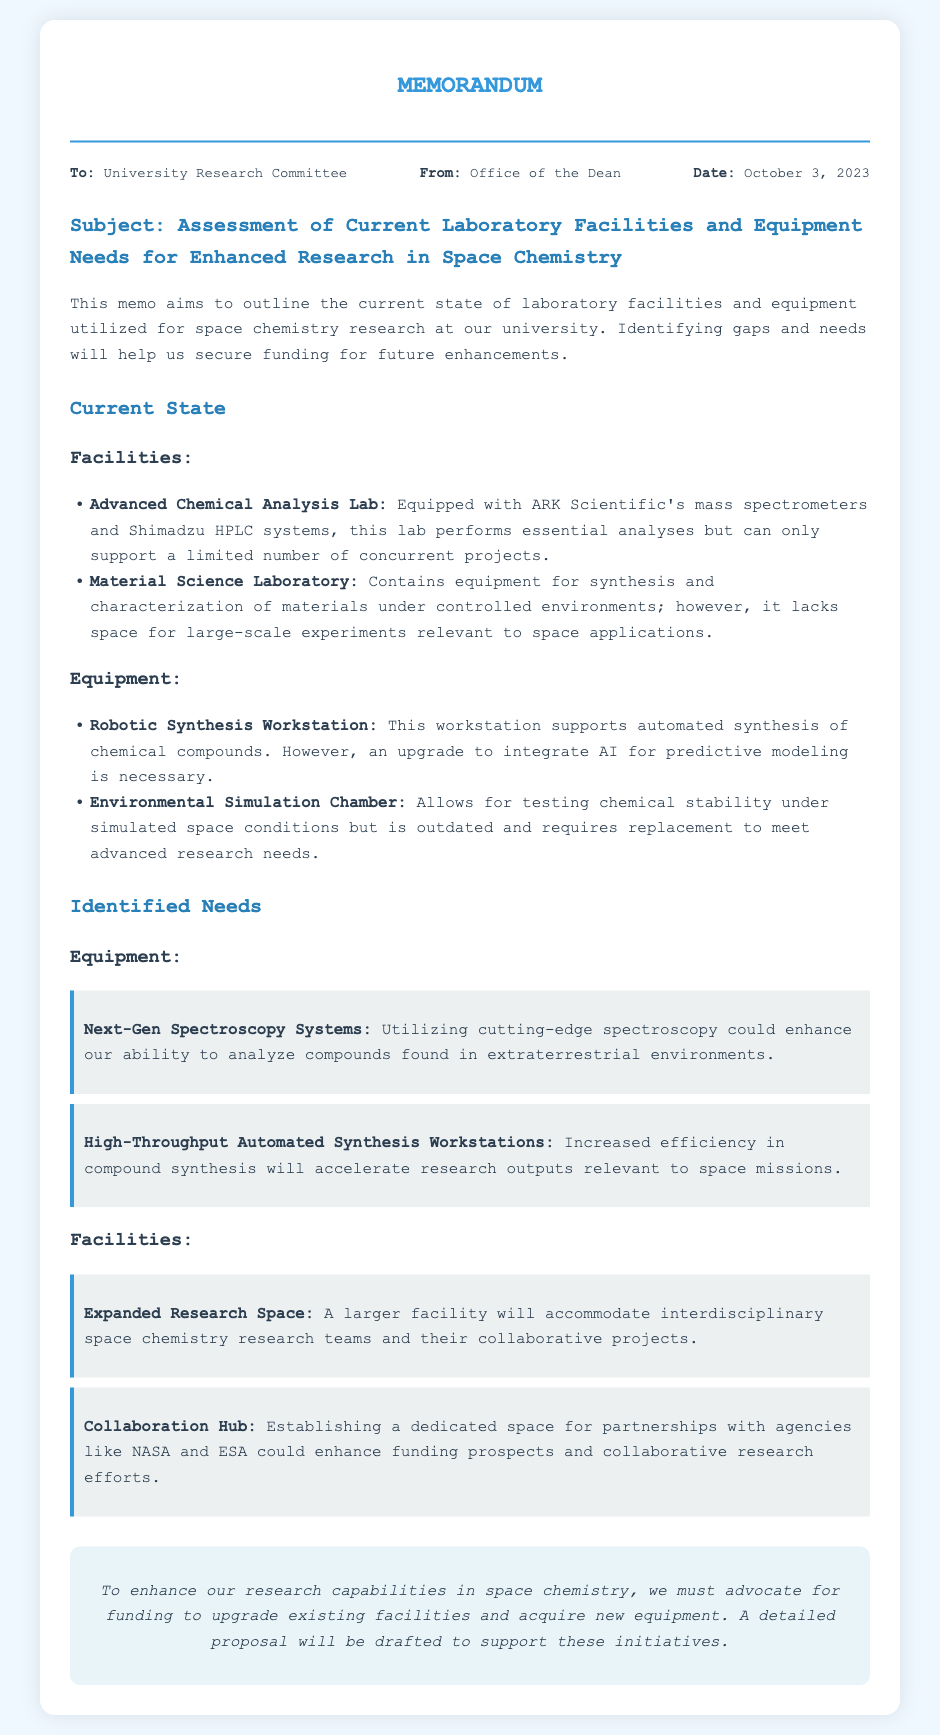What is the date of the memo? The date of the memo is indicated at the top as October 3, 2023.
Answer: October 3, 2023 Who is the memo addressed to? The memorandum specifies that it is addressed to the University Research Committee.
Answer: University Research Committee What is the main subject of the memo? The main subject focuses on the assessment of current laboratory facilities and equipment needs for enhanced research in space chemistry.
Answer: Assessment of Current Laboratory Facilities and Equipment Needs for Enhanced Research in Space Chemistry What type of equipment does the Advanced Chemical Analysis Lab use? The memo mentions that the lab is equipped with ARK Scientific's mass spectrometers and Shimadzu HPLC systems.
Answer: ARK Scientific's mass spectrometers and Shimadzu HPLC systems What is one identified need for equipment? The memo highlights that Next-Gen Spectroscopy Systems could enhance analysis capabilities for extraterrestrial compounds.
Answer: Next-Gen Spectroscopy Systems How many labs are specifically mentioned in the document? There are two laboratories specifically detailed in the memo: the Advanced Chemical Analysis Lab and the Material Science Laboratory.
Answer: Two What is the purpose of the expanded research space mentioned in the memo? The expanded research space aims to accommodate interdisciplinary space chemistry research teams and collaborative projects.
Answer: To accommodate interdisciplinary space chemistry research teams What could establishing a Collaboration Hub enhance? The Collaboration Hub might enhance funding prospects and collaborative research efforts with agencies like NASA and ESA.
Answer: Funding prospects and collaborative research efforts What will the Office of the Dean draft to support initiatives? The Office of the Dean plans to draft a detailed proposal to support the initiatives outlined in the memo.
Answer: A detailed proposal 